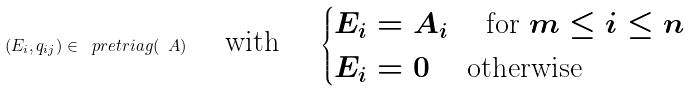Convert formula to latex. <formula><loc_0><loc_0><loc_500><loc_500>( E _ { i } , q _ { i j } ) \in \ p r e t r i a g ( \ A ) \quad \text { with } \quad \begin{cases} E _ { i } = A _ { i } \quad \text { for } m \leq i \leq n \\ E _ { i } = 0 \quad \text { otherwise } \end{cases}</formula> 